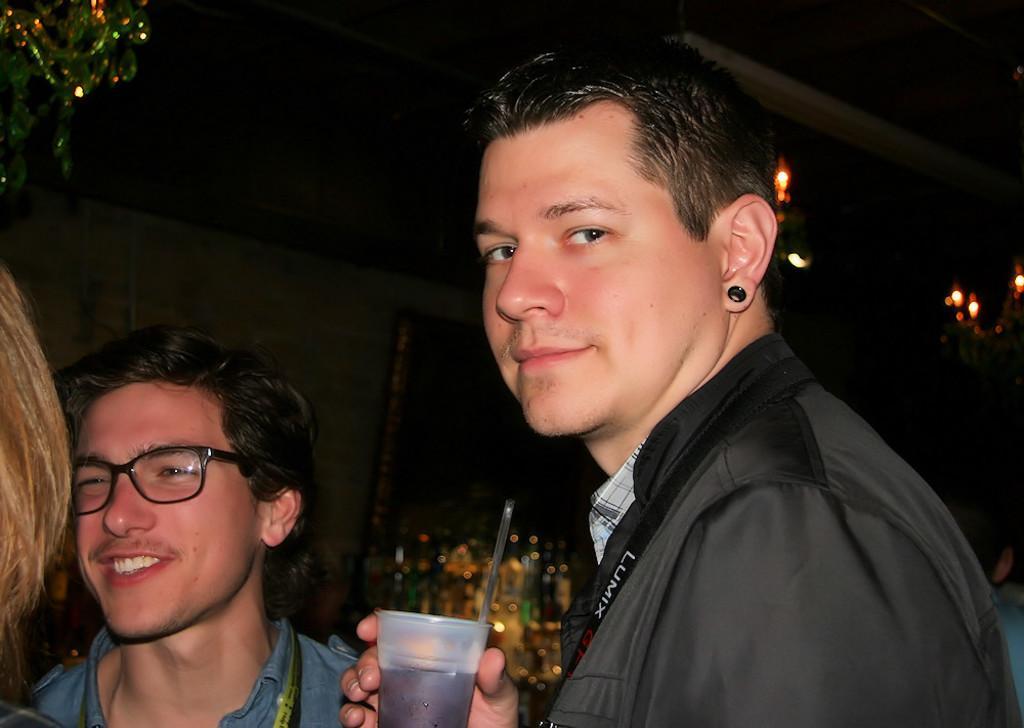Can you describe this image briefly? In the foreground of the image there is person wearing a jacket and holding a glass in his hand. To the left side of the image there are people. In the background of the image there is wall. At the top of the image there is ceiling with lights. 